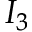Convert formula to latex. <formula><loc_0><loc_0><loc_500><loc_500>I _ { 3 }</formula> 